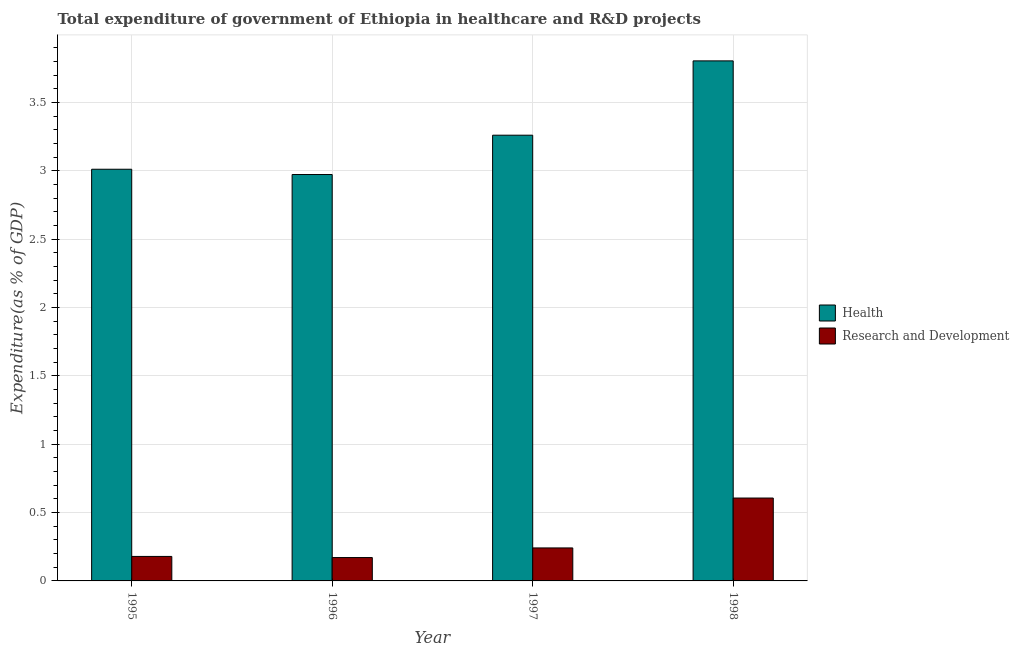How many different coloured bars are there?
Give a very brief answer. 2. Are the number of bars on each tick of the X-axis equal?
Keep it short and to the point. Yes. What is the expenditure in healthcare in 1998?
Your answer should be compact. 3.8. Across all years, what is the maximum expenditure in healthcare?
Your answer should be very brief. 3.8. Across all years, what is the minimum expenditure in healthcare?
Provide a succinct answer. 2.97. What is the total expenditure in healthcare in the graph?
Make the answer very short. 13.05. What is the difference between the expenditure in r&d in 1996 and that in 1997?
Offer a very short reply. -0.07. What is the difference between the expenditure in healthcare in 1997 and the expenditure in r&d in 1995?
Provide a short and direct response. 0.25. What is the average expenditure in r&d per year?
Give a very brief answer. 0.3. What is the ratio of the expenditure in healthcare in 1997 to that in 1998?
Make the answer very short. 0.86. Is the difference between the expenditure in healthcare in 1995 and 1996 greater than the difference between the expenditure in r&d in 1995 and 1996?
Ensure brevity in your answer.  No. What is the difference between the highest and the second highest expenditure in healthcare?
Your answer should be compact. 0.54. What is the difference between the highest and the lowest expenditure in healthcare?
Your response must be concise. 0.83. What does the 1st bar from the left in 1998 represents?
Keep it short and to the point. Health. What does the 1st bar from the right in 1995 represents?
Ensure brevity in your answer.  Research and Development. What is the difference between two consecutive major ticks on the Y-axis?
Make the answer very short. 0.5. Does the graph contain grids?
Make the answer very short. Yes. Where does the legend appear in the graph?
Your response must be concise. Center right. How are the legend labels stacked?
Provide a short and direct response. Vertical. What is the title of the graph?
Give a very brief answer. Total expenditure of government of Ethiopia in healthcare and R&D projects. Does "current US$" appear as one of the legend labels in the graph?
Your response must be concise. No. What is the label or title of the Y-axis?
Your answer should be compact. Expenditure(as % of GDP). What is the Expenditure(as % of GDP) of Health in 1995?
Offer a very short reply. 3.01. What is the Expenditure(as % of GDP) in Research and Development in 1995?
Make the answer very short. 0.18. What is the Expenditure(as % of GDP) in Health in 1996?
Provide a succinct answer. 2.97. What is the Expenditure(as % of GDP) in Research and Development in 1996?
Your response must be concise. 0.17. What is the Expenditure(as % of GDP) in Health in 1997?
Provide a succinct answer. 3.26. What is the Expenditure(as % of GDP) in Research and Development in 1997?
Keep it short and to the point. 0.24. What is the Expenditure(as % of GDP) of Health in 1998?
Your answer should be very brief. 3.8. What is the Expenditure(as % of GDP) in Research and Development in 1998?
Keep it short and to the point. 0.61. Across all years, what is the maximum Expenditure(as % of GDP) of Health?
Offer a very short reply. 3.8. Across all years, what is the maximum Expenditure(as % of GDP) of Research and Development?
Offer a very short reply. 0.61. Across all years, what is the minimum Expenditure(as % of GDP) of Health?
Offer a terse response. 2.97. Across all years, what is the minimum Expenditure(as % of GDP) in Research and Development?
Offer a terse response. 0.17. What is the total Expenditure(as % of GDP) of Health in the graph?
Provide a succinct answer. 13.05. What is the total Expenditure(as % of GDP) of Research and Development in the graph?
Provide a short and direct response. 1.2. What is the difference between the Expenditure(as % of GDP) in Health in 1995 and that in 1996?
Offer a very short reply. 0.04. What is the difference between the Expenditure(as % of GDP) in Research and Development in 1995 and that in 1996?
Provide a succinct answer. 0.01. What is the difference between the Expenditure(as % of GDP) in Health in 1995 and that in 1997?
Provide a succinct answer. -0.25. What is the difference between the Expenditure(as % of GDP) of Research and Development in 1995 and that in 1997?
Provide a short and direct response. -0.06. What is the difference between the Expenditure(as % of GDP) in Health in 1995 and that in 1998?
Keep it short and to the point. -0.79. What is the difference between the Expenditure(as % of GDP) of Research and Development in 1995 and that in 1998?
Your response must be concise. -0.43. What is the difference between the Expenditure(as % of GDP) of Health in 1996 and that in 1997?
Your response must be concise. -0.29. What is the difference between the Expenditure(as % of GDP) of Research and Development in 1996 and that in 1997?
Give a very brief answer. -0.07. What is the difference between the Expenditure(as % of GDP) of Health in 1996 and that in 1998?
Give a very brief answer. -0.83. What is the difference between the Expenditure(as % of GDP) in Research and Development in 1996 and that in 1998?
Offer a very short reply. -0.44. What is the difference between the Expenditure(as % of GDP) in Health in 1997 and that in 1998?
Provide a short and direct response. -0.54. What is the difference between the Expenditure(as % of GDP) of Research and Development in 1997 and that in 1998?
Make the answer very short. -0.36. What is the difference between the Expenditure(as % of GDP) in Health in 1995 and the Expenditure(as % of GDP) in Research and Development in 1996?
Ensure brevity in your answer.  2.84. What is the difference between the Expenditure(as % of GDP) in Health in 1995 and the Expenditure(as % of GDP) in Research and Development in 1997?
Give a very brief answer. 2.77. What is the difference between the Expenditure(as % of GDP) of Health in 1995 and the Expenditure(as % of GDP) of Research and Development in 1998?
Give a very brief answer. 2.41. What is the difference between the Expenditure(as % of GDP) in Health in 1996 and the Expenditure(as % of GDP) in Research and Development in 1997?
Offer a very short reply. 2.73. What is the difference between the Expenditure(as % of GDP) in Health in 1996 and the Expenditure(as % of GDP) in Research and Development in 1998?
Offer a terse response. 2.37. What is the difference between the Expenditure(as % of GDP) in Health in 1997 and the Expenditure(as % of GDP) in Research and Development in 1998?
Your answer should be very brief. 2.65. What is the average Expenditure(as % of GDP) in Health per year?
Ensure brevity in your answer.  3.26. What is the average Expenditure(as % of GDP) in Research and Development per year?
Provide a short and direct response. 0.3. In the year 1995, what is the difference between the Expenditure(as % of GDP) of Health and Expenditure(as % of GDP) of Research and Development?
Offer a very short reply. 2.83. In the year 1996, what is the difference between the Expenditure(as % of GDP) of Health and Expenditure(as % of GDP) of Research and Development?
Give a very brief answer. 2.8. In the year 1997, what is the difference between the Expenditure(as % of GDP) of Health and Expenditure(as % of GDP) of Research and Development?
Your answer should be compact. 3.02. In the year 1998, what is the difference between the Expenditure(as % of GDP) of Health and Expenditure(as % of GDP) of Research and Development?
Provide a short and direct response. 3.2. What is the ratio of the Expenditure(as % of GDP) in Research and Development in 1995 to that in 1996?
Your response must be concise. 1.05. What is the ratio of the Expenditure(as % of GDP) of Health in 1995 to that in 1997?
Keep it short and to the point. 0.92. What is the ratio of the Expenditure(as % of GDP) of Research and Development in 1995 to that in 1997?
Your response must be concise. 0.74. What is the ratio of the Expenditure(as % of GDP) in Health in 1995 to that in 1998?
Give a very brief answer. 0.79. What is the ratio of the Expenditure(as % of GDP) in Research and Development in 1995 to that in 1998?
Keep it short and to the point. 0.3. What is the ratio of the Expenditure(as % of GDP) of Health in 1996 to that in 1997?
Offer a terse response. 0.91. What is the ratio of the Expenditure(as % of GDP) of Research and Development in 1996 to that in 1997?
Provide a short and direct response. 0.71. What is the ratio of the Expenditure(as % of GDP) of Health in 1996 to that in 1998?
Ensure brevity in your answer.  0.78. What is the ratio of the Expenditure(as % of GDP) of Research and Development in 1996 to that in 1998?
Give a very brief answer. 0.28. What is the ratio of the Expenditure(as % of GDP) in Research and Development in 1997 to that in 1998?
Your answer should be compact. 0.4. What is the difference between the highest and the second highest Expenditure(as % of GDP) of Health?
Your response must be concise. 0.54. What is the difference between the highest and the second highest Expenditure(as % of GDP) in Research and Development?
Offer a very short reply. 0.36. What is the difference between the highest and the lowest Expenditure(as % of GDP) in Health?
Your response must be concise. 0.83. What is the difference between the highest and the lowest Expenditure(as % of GDP) of Research and Development?
Offer a terse response. 0.44. 